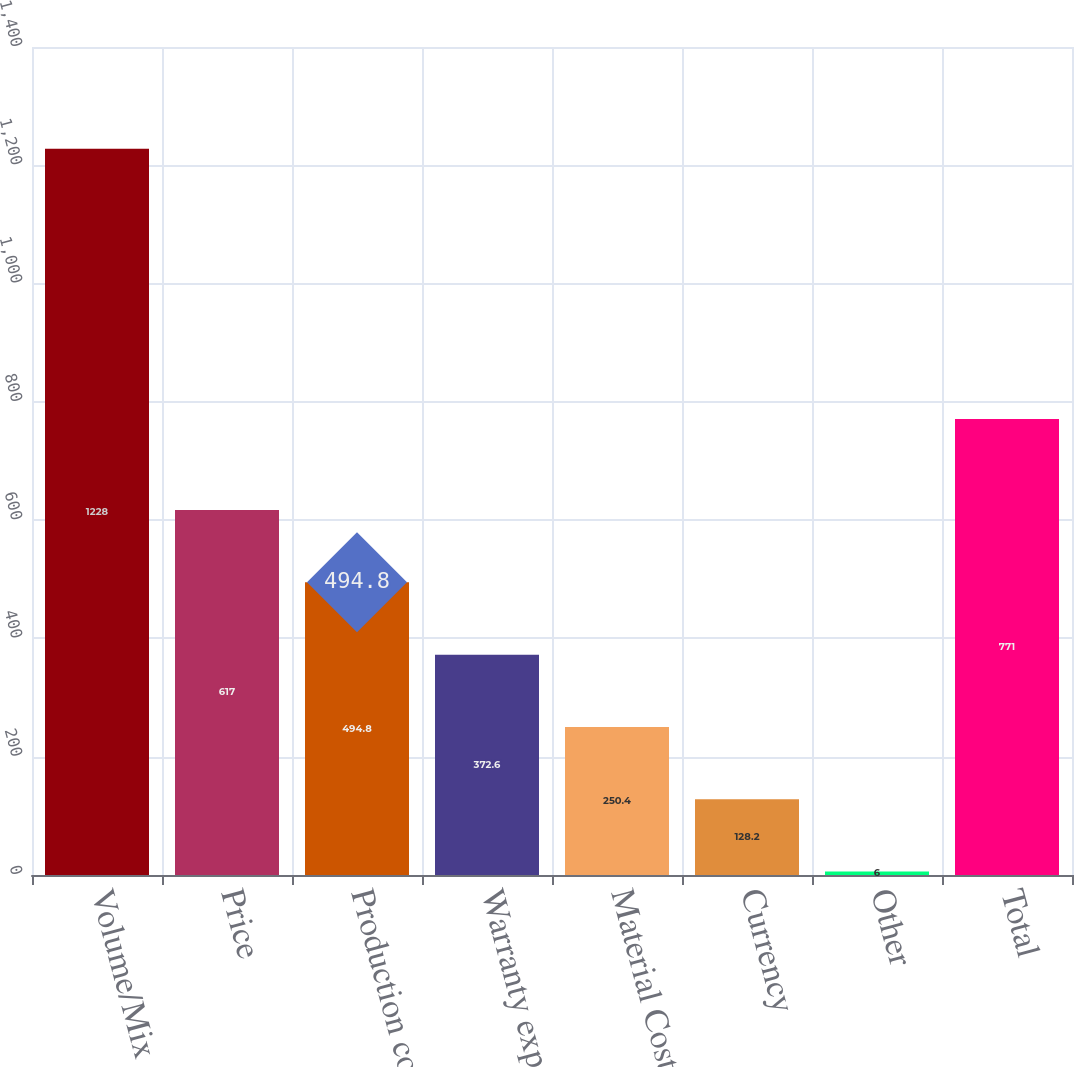Convert chart to OTSL. <chart><loc_0><loc_0><loc_500><loc_500><bar_chart><fcel>Volume/Mix<fcel>Price<fcel>Production costs<fcel>Warranty expense<fcel>Material Costs<fcel>Currency<fcel>Other<fcel>Total<nl><fcel>1228<fcel>617<fcel>494.8<fcel>372.6<fcel>250.4<fcel>128.2<fcel>6<fcel>771<nl></chart> 